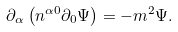Convert formula to latex. <formula><loc_0><loc_0><loc_500><loc_500>\partial _ { \alpha } \left ( n ^ { \alpha 0 } \partial _ { 0 } \Psi \right ) = - m ^ { 2 } \Psi .</formula> 